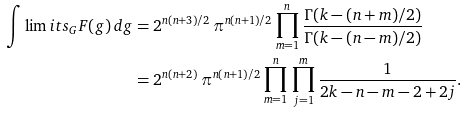<formula> <loc_0><loc_0><loc_500><loc_500>\int \lim i t s _ { G } F ( g ) \, d g & = 2 ^ { n ( n + 3 ) / 2 } \, \pi ^ { n ( n + 1 ) / 2 } \prod _ { m = 1 } ^ { n } \frac { \Gamma ( k - ( n + m ) / 2 ) } { \Gamma ( k - ( n - m ) / 2 ) } \\ & = 2 ^ { n ( n + 2 ) } \, \pi ^ { n ( n + 1 ) / 2 } \prod _ { m = 1 } ^ { n } \, \prod _ { j = 1 } ^ { m } \frac { 1 } { 2 k - n - m - 2 + 2 j } .</formula> 